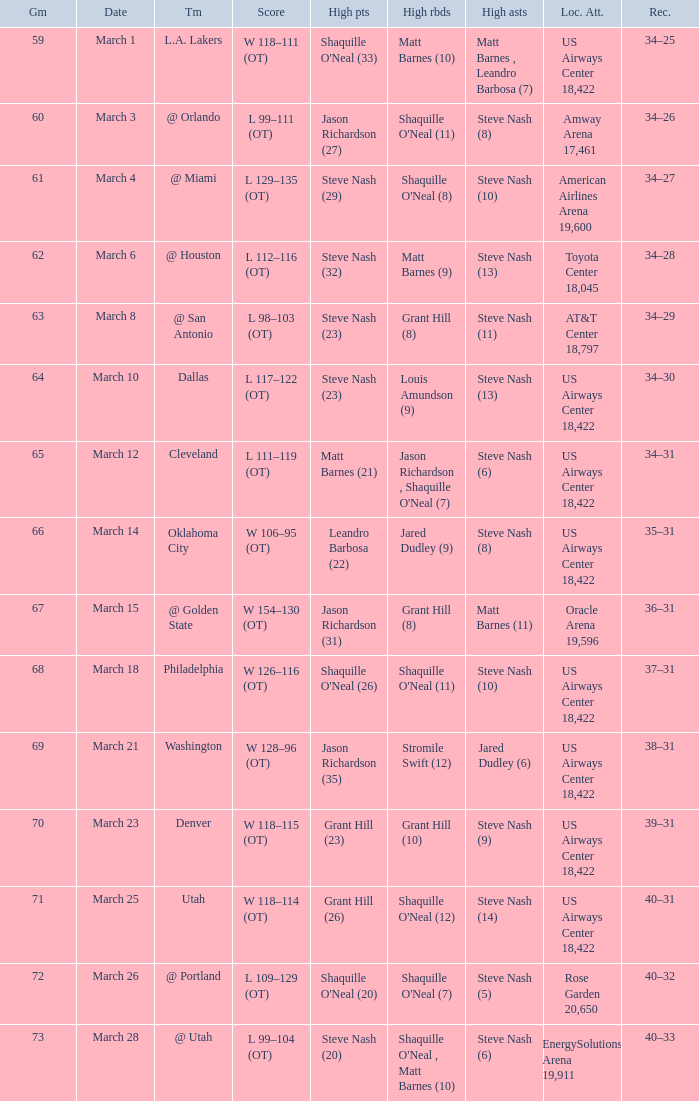Write the full table. {'header': ['Gm', 'Date', 'Tm', 'Score', 'High pts', 'High rbds', 'High asts', 'Loc. Att.', 'Rec.'], 'rows': [['59', 'March 1', 'L.A. Lakers', 'W 118–111 (OT)', "Shaquille O'Neal (33)", 'Matt Barnes (10)', 'Matt Barnes , Leandro Barbosa (7)', 'US Airways Center 18,422', '34–25'], ['60', 'March 3', '@ Orlando', 'L 99–111 (OT)', 'Jason Richardson (27)', "Shaquille O'Neal (11)", 'Steve Nash (8)', 'Amway Arena 17,461', '34–26'], ['61', 'March 4', '@ Miami', 'L 129–135 (OT)', 'Steve Nash (29)', "Shaquille O'Neal (8)", 'Steve Nash (10)', 'American Airlines Arena 19,600', '34–27'], ['62', 'March 6', '@ Houston', 'L 112–116 (OT)', 'Steve Nash (32)', 'Matt Barnes (9)', 'Steve Nash (13)', 'Toyota Center 18,045', '34–28'], ['63', 'March 8', '@ San Antonio', 'L 98–103 (OT)', 'Steve Nash (23)', 'Grant Hill (8)', 'Steve Nash (11)', 'AT&T Center 18,797', '34–29'], ['64', 'March 10', 'Dallas', 'L 117–122 (OT)', 'Steve Nash (23)', 'Louis Amundson (9)', 'Steve Nash (13)', 'US Airways Center 18,422', '34–30'], ['65', 'March 12', 'Cleveland', 'L 111–119 (OT)', 'Matt Barnes (21)', "Jason Richardson , Shaquille O'Neal (7)", 'Steve Nash (6)', 'US Airways Center 18,422', '34–31'], ['66', 'March 14', 'Oklahoma City', 'W 106–95 (OT)', 'Leandro Barbosa (22)', 'Jared Dudley (9)', 'Steve Nash (8)', 'US Airways Center 18,422', '35–31'], ['67', 'March 15', '@ Golden State', 'W 154–130 (OT)', 'Jason Richardson (31)', 'Grant Hill (8)', 'Matt Barnes (11)', 'Oracle Arena 19,596', '36–31'], ['68', 'March 18', 'Philadelphia', 'W 126–116 (OT)', "Shaquille O'Neal (26)", "Shaquille O'Neal (11)", 'Steve Nash (10)', 'US Airways Center 18,422', '37–31'], ['69', 'March 21', 'Washington', 'W 128–96 (OT)', 'Jason Richardson (35)', 'Stromile Swift (12)', 'Jared Dudley (6)', 'US Airways Center 18,422', '38–31'], ['70', 'March 23', 'Denver', 'W 118–115 (OT)', 'Grant Hill (23)', 'Grant Hill (10)', 'Steve Nash (9)', 'US Airways Center 18,422', '39–31'], ['71', 'March 25', 'Utah', 'W 118–114 (OT)', 'Grant Hill (26)', "Shaquille O'Neal (12)", 'Steve Nash (14)', 'US Airways Center 18,422', '40–31'], ['72', 'March 26', '@ Portland', 'L 109–129 (OT)', "Shaquille O'Neal (20)", "Shaquille O'Neal (7)", 'Steve Nash (5)', 'Rose Garden 20,650', '40–32'], ['73', 'March 28', '@ Utah', 'L 99–104 (OT)', 'Steve Nash (20)', "Shaquille O'Neal , Matt Barnes (10)", 'Steve Nash (6)', 'EnergySolutions Arena 19,911', '40–33']]} After the March 15 game, what was the team's record? 36–31. 